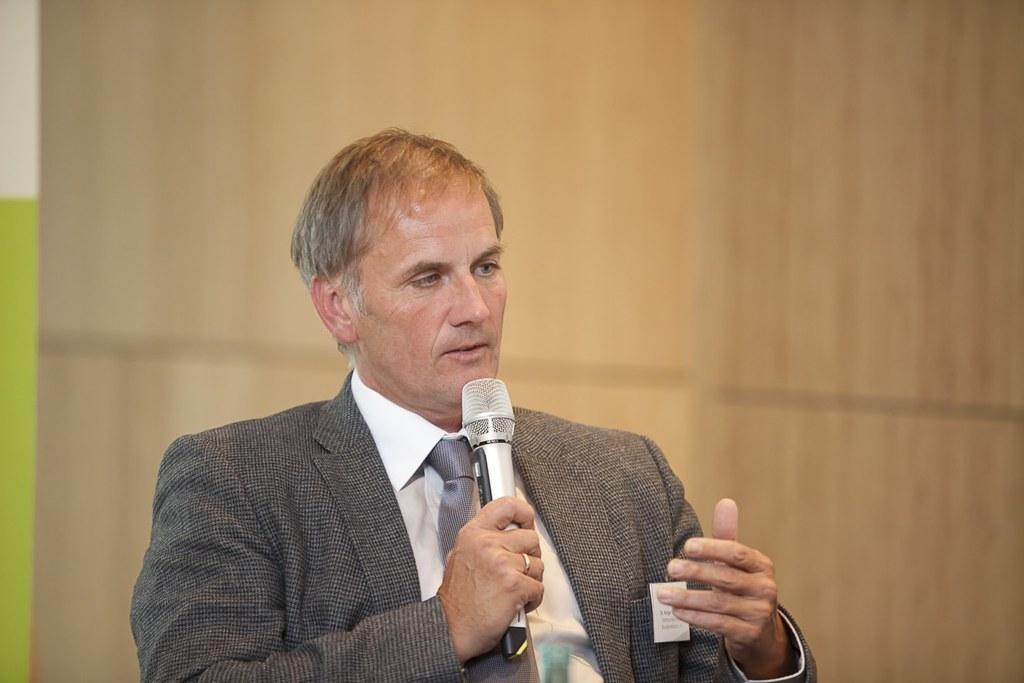Could you give a brief overview of what you see in this image? In this picture, we see a man in grey blazer and white shirt is holding microphone in his hand and he might be talking on it. Behind him, we see a wall. 